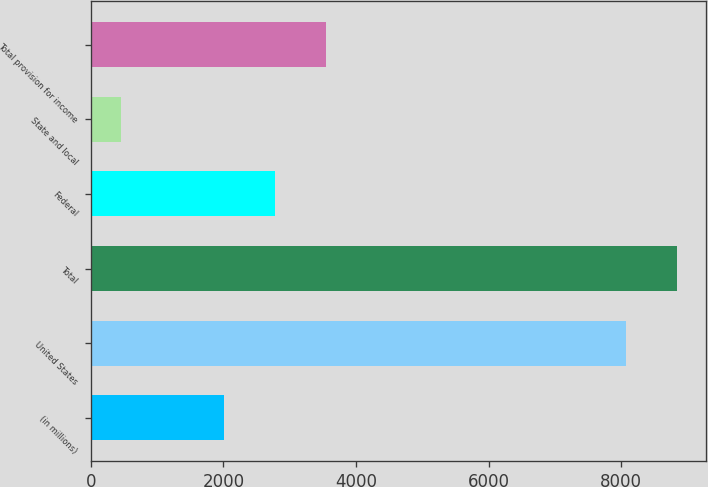<chart> <loc_0><loc_0><loc_500><loc_500><bar_chart><fcel>(in millions)<fcel>United States<fcel>Total<fcel>Federal<fcel>State and local<fcel>Total provision for income<nl><fcel>2015<fcel>8078<fcel>8840.7<fcel>2777.7<fcel>451<fcel>3540.4<nl></chart> 